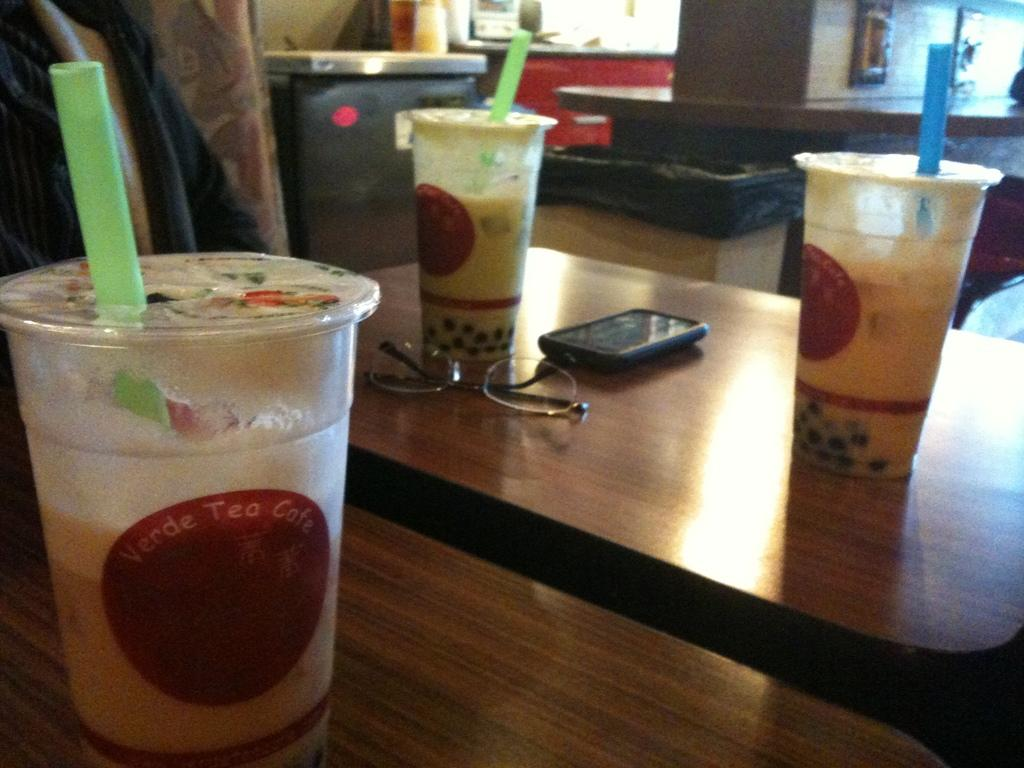<image>
Write a terse but informative summary of the picture. several bubble teas from Verde Tea Cafe on table 